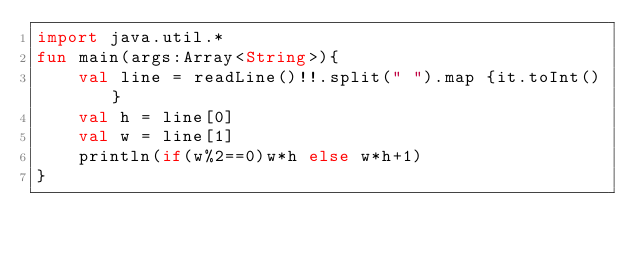Convert code to text. <code><loc_0><loc_0><loc_500><loc_500><_Kotlin_>import java.util.*
fun main(args:Array<String>){
    val line = readLine()!!.split(" ").map {it.toInt()}
    val h = line[0]
    val w = line[1]
    println(if(w%2==0)w*h else w*h+1)
}</code> 